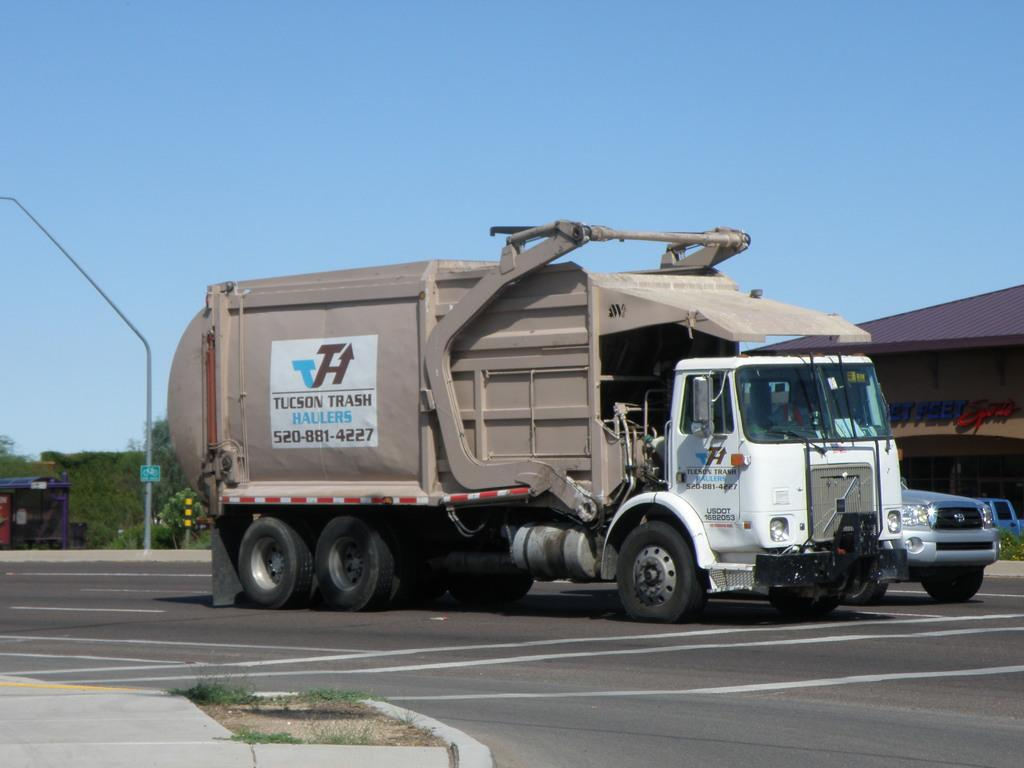What can be seen on the road in the image? There are vehicles on the road in the image. What is located on the left side of the image? There is a pole on the left side of the image. What is visible in the background of the image? There is a shed and trees visible in the background of the image. What is visible at the top of the image? The sky is visible at the top of the image. How many fish can be seen swimming in the sky in the image? There are no fish visible in the sky in the image. What type of library is located on the right side of the image? There is no library present in the image. 